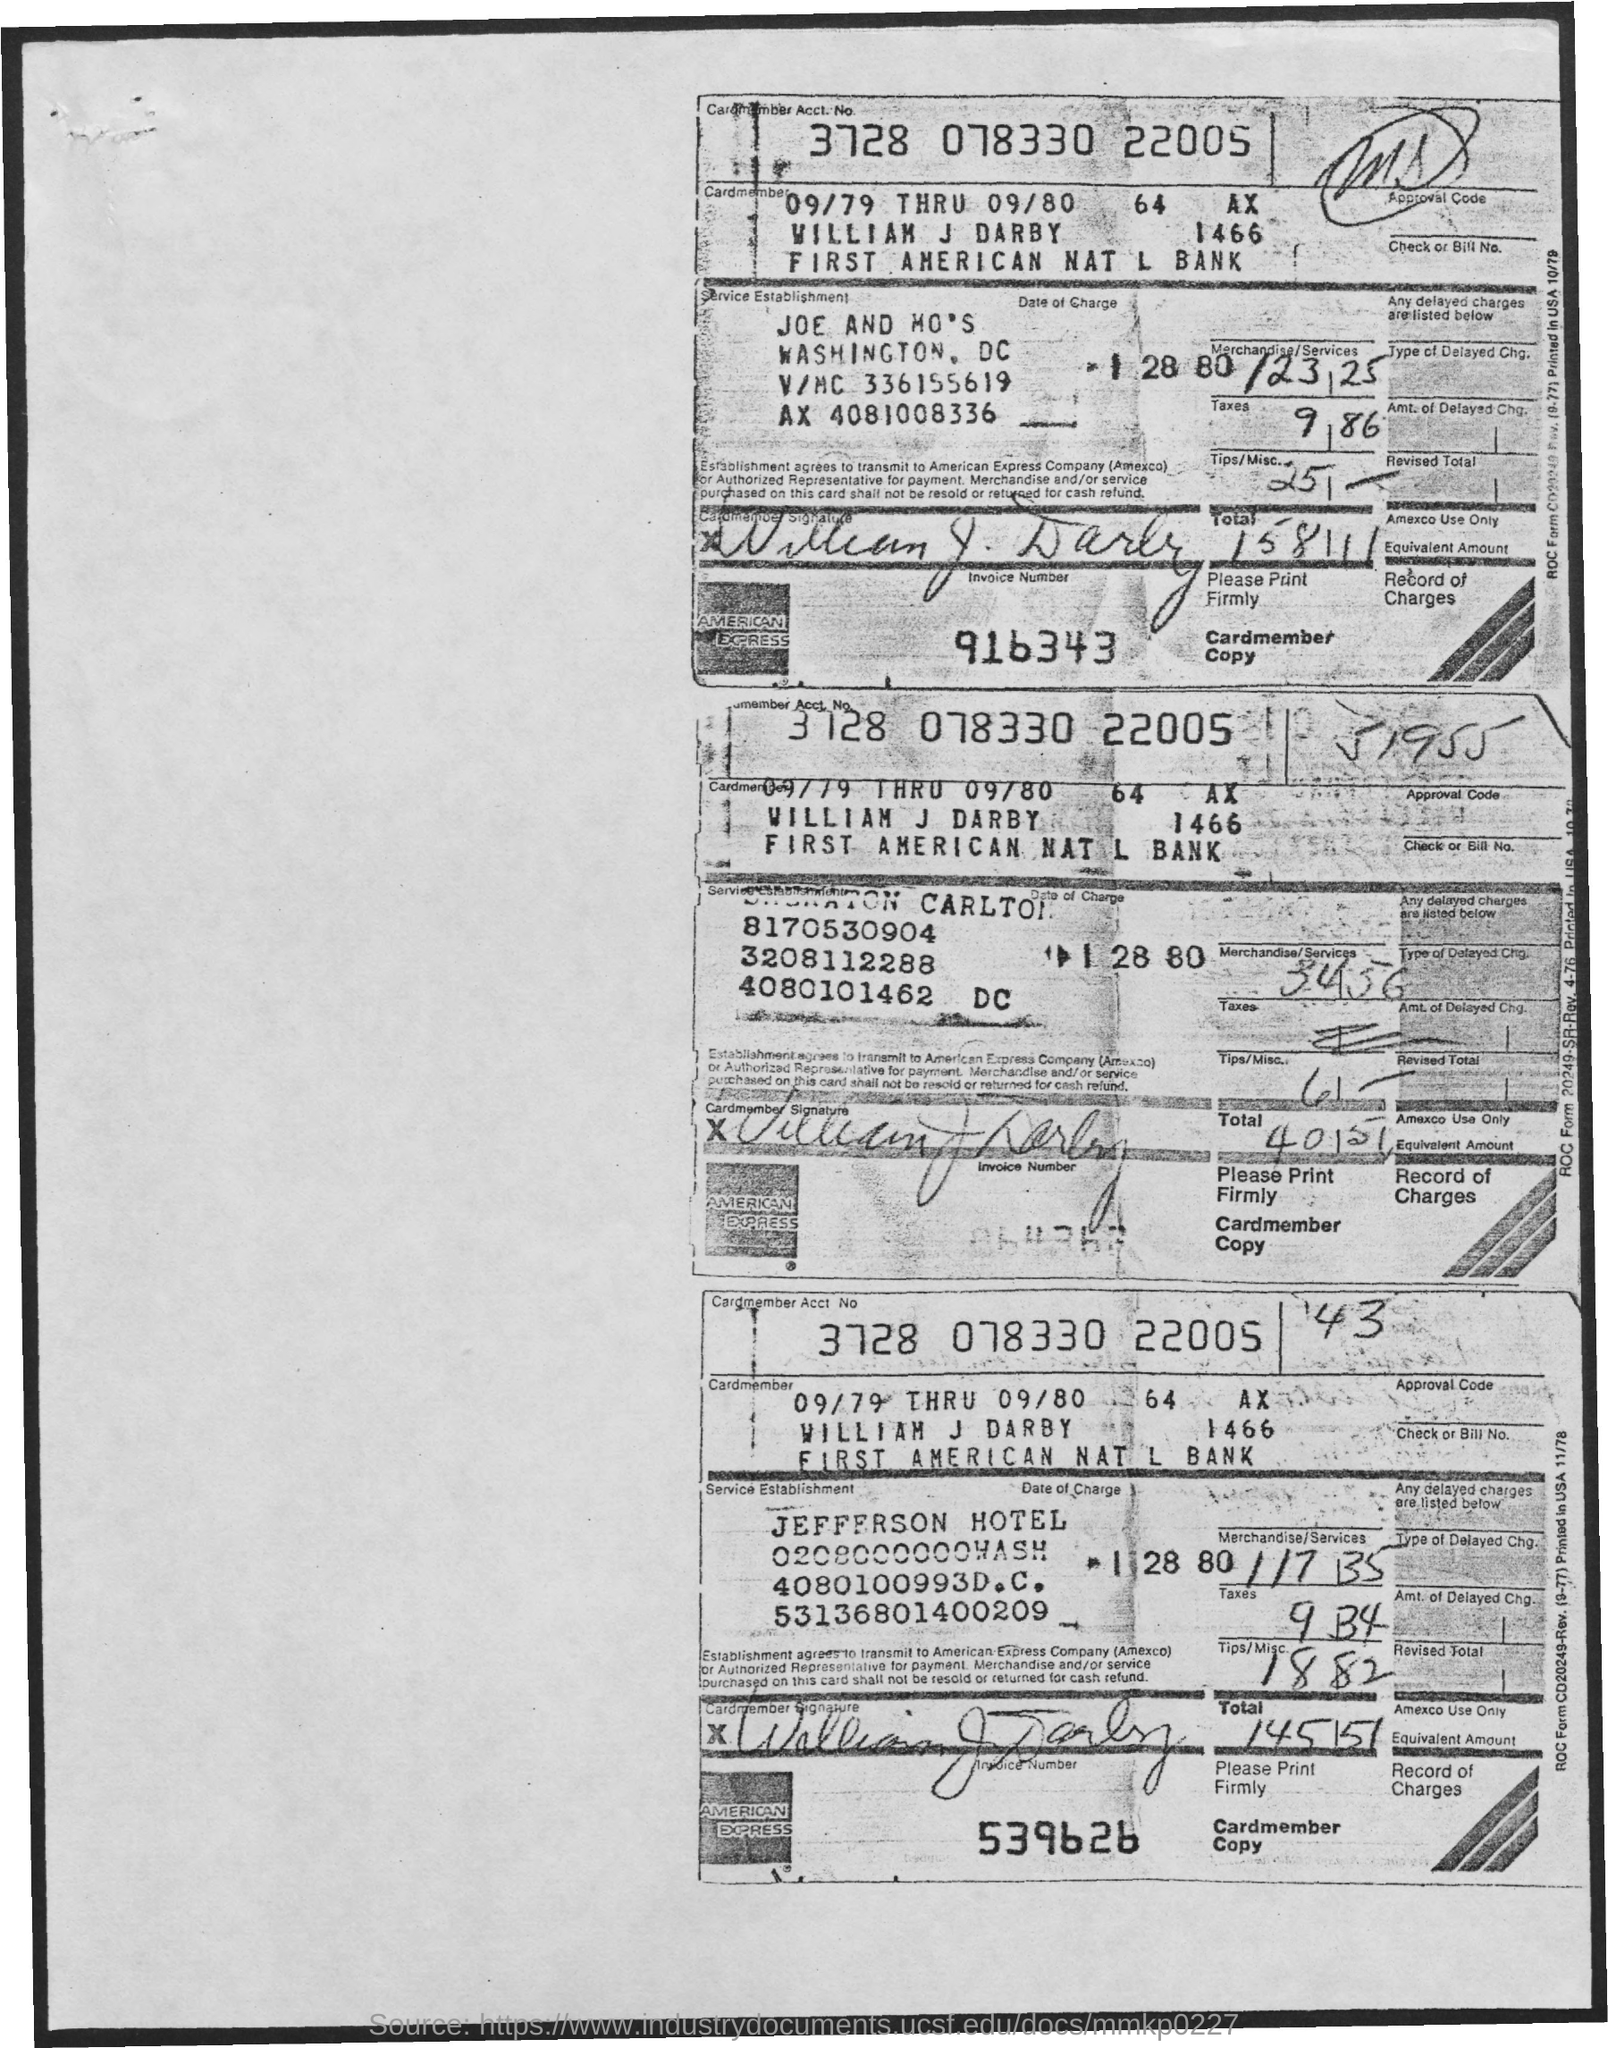What is the Cardmember Acct No.?
Your response must be concise. 3728 078330 22005. 